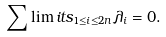Convert formula to latex. <formula><loc_0><loc_0><loc_500><loc_500>\sum \lim i t s _ { 1 \leq i \leq 2 n } \lambda _ { i } = 0 .</formula> 